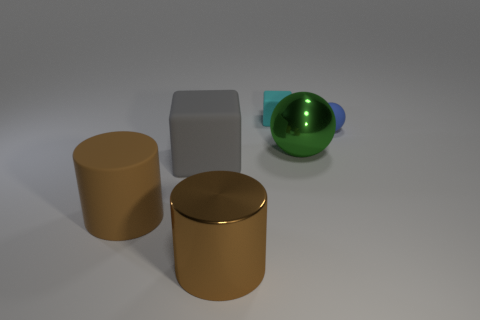Add 1 big brown rubber blocks. How many objects exist? 7 Subtract all cubes. How many objects are left? 4 Subtract all brown cylinders. Subtract all blue balls. How many objects are left? 3 Add 3 small cyan things. How many small cyan things are left? 4 Add 4 spheres. How many spheres exist? 6 Subtract 0 yellow blocks. How many objects are left? 6 